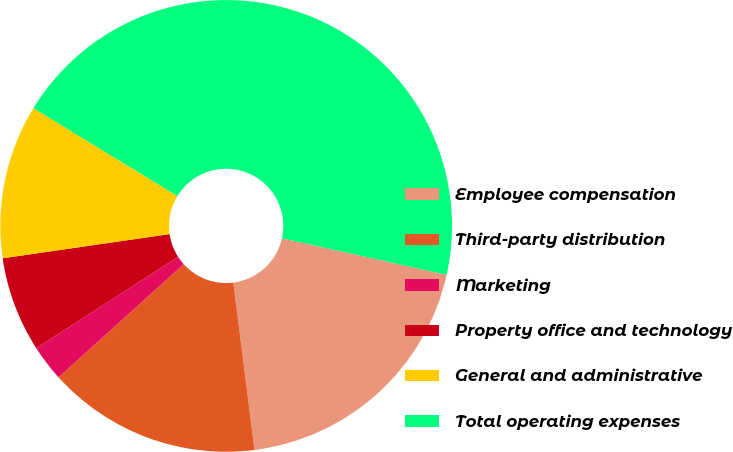Convert chart to OTSL. <chart><loc_0><loc_0><loc_500><loc_500><pie_chart><fcel>Employee compensation<fcel>Third-party distribution<fcel>Marketing<fcel>Property office and technology<fcel>General and administrative<fcel>Total operating expenses<nl><fcel>19.52%<fcel>15.31%<fcel>2.59%<fcel>6.81%<fcel>11.02%<fcel>44.75%<nl></chart> 